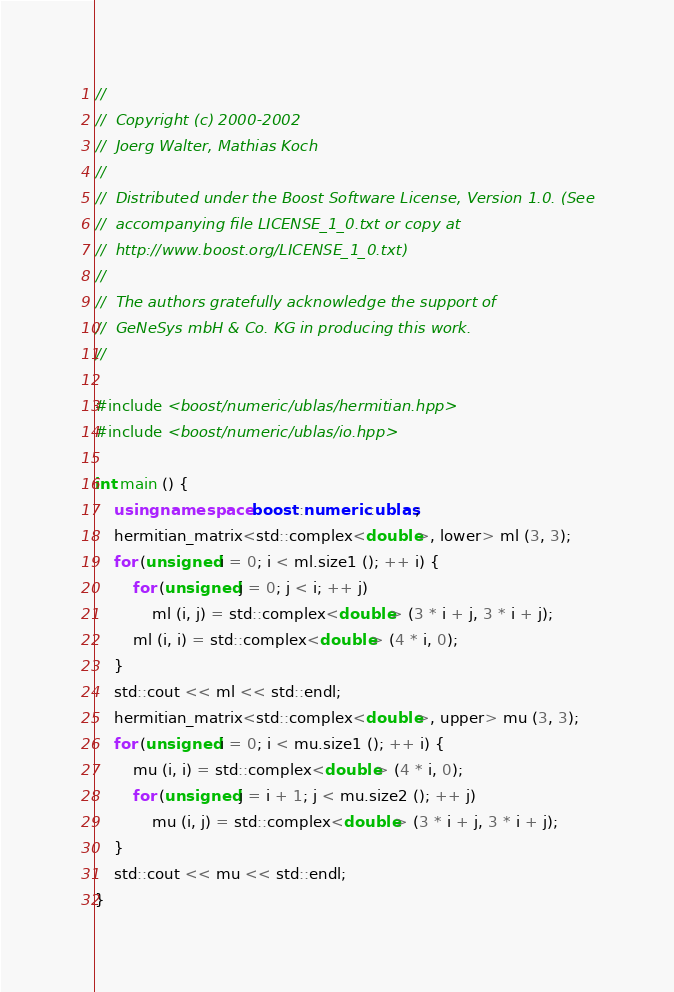Convert code to text. <code><loc_0><loc_0><loc_500><loc_500><_C++_>//
//  Copyright (c) 2000-2002
//  Joerg Walter, Mathias Koch
//
//  Distributed under the Boost Software License, Version 1.0. (See
//  accompanying file LICENSE_1_0.txt or copy at
//  http://www.boost.org/LICENSE_1_0.txt)
//
//  The authors gratefully acknowledge the support of
//  GeNeSys mbH & Co. KG in producing this work.
//

#include <boost/numeric/ublas/hermitian.hpp>
#include <boost/numeric/ublas/io.hpp>

int main () {
    using namespace boost::numeric::ublas;
    hermitian_matrix<std::complex<double>, lower> ml (3, 3);
    for (unsigned i = 0; i < ml.size1 (); ++ i) {
        for (unsigned j = 0; j < i; ++ j)
            ml (i, j) = std::complex<double> (3 * i + j, 3 * i + j);
        ml (i, i) = std::complex<double> (4 * i, 0);
    }
    std::cout << ml << std::endl;
    hermitian_matrix<std::complex<double>, upper> mu (3, 3);
    for (unsigned i = 0; i < mu.size1 (); ++ i) {
        mu (i, i) = std::complex<double> (4 * i, 0);
        for (unsigned j = i + 1; j < mu.size2 (); ++ j)
            mu (i, j) = std::complex<double> (3 * i + j, 3 * i + j);
    }
    std::cout << mu << std::endl;
}

</code> 